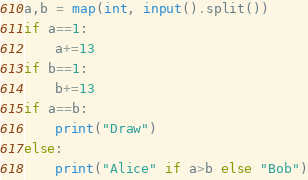<code> <loc_0><loc_0><loc_500><loc_500><_Python_>a,b = map(int, input().split())
if a==1:
    a+=13
if b==1:
    b+=13
if a==b:
    print("Draw")
else:
    print("Alice" if a>b else "Bob")</code> 